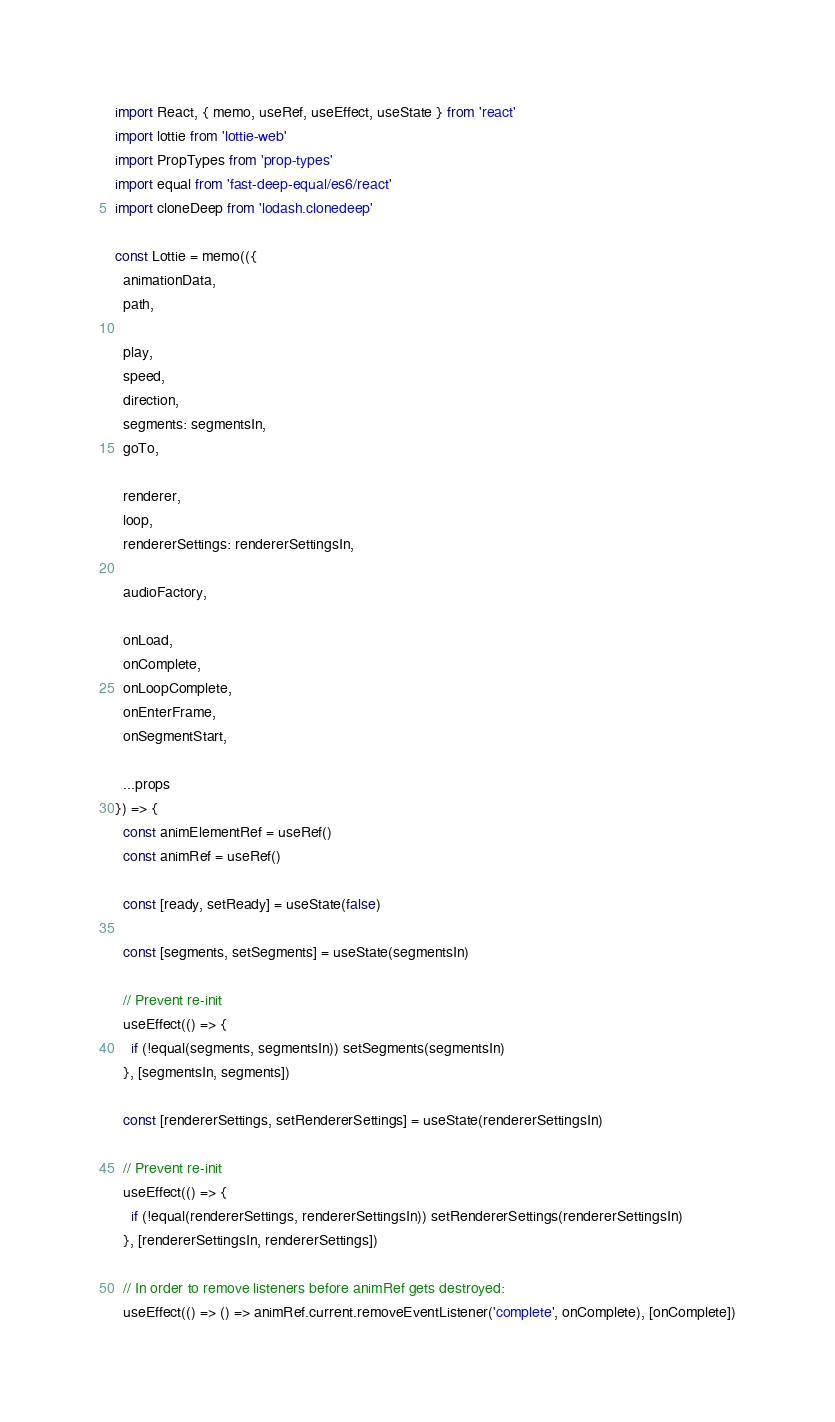Convert code to text. <code><loc_0><loc_0><loc_500><loc_500><_JavaScript_>import React, { memo, useRef, useEffect, useState } from 'react'
import lottie from 'lottie-web'
import PropTypes from 'prop-types'
import equal from 'fast-deep-equal/es6/react'
import cloneDeep from 'lodash.clonedeep'

const Lottie = memo(({
  animationData,
  path,

  play,
  speed,
  direction,
  segments: segmentsIn,
  goTo,

  renderer,
  loop,
  rendererSettings: rendererSettingsIn,

  audioFactory,

  onLoad,
  onComplete,
  onLoopComplete,
  onEnterFrame,
  onSegmentStart,

  ...props
}) => {
  const animElementRef = useRef()
  const animRef = useRef()

  const [ready, setReady] = useState(false)

  const [segments, setSegments] = useState(segmentsIn)

  // Prevent re-init
  useEffect(() => {
    if (!equal(segments, segmentsIn)) setSegments(segmentsIn)
  }, [segmentsIn, segments])

  const [rendererSettings, setRendererSettings] = useState(rendererSettingsIn)

  // Prevent re-init
  useEffect(() => {
    if (!equal(rendererSettings, rendererSettingsIn)) setRendererSettings(rendererSettingsIn)
  }, [rendererSettingsIn, rendererSettings])

  // In order to remove listeners before animRef gets destroyed:
  useEffect(() => () => animRef.current.removeEventListener('complete', onComplete), [onComplete])</code> 